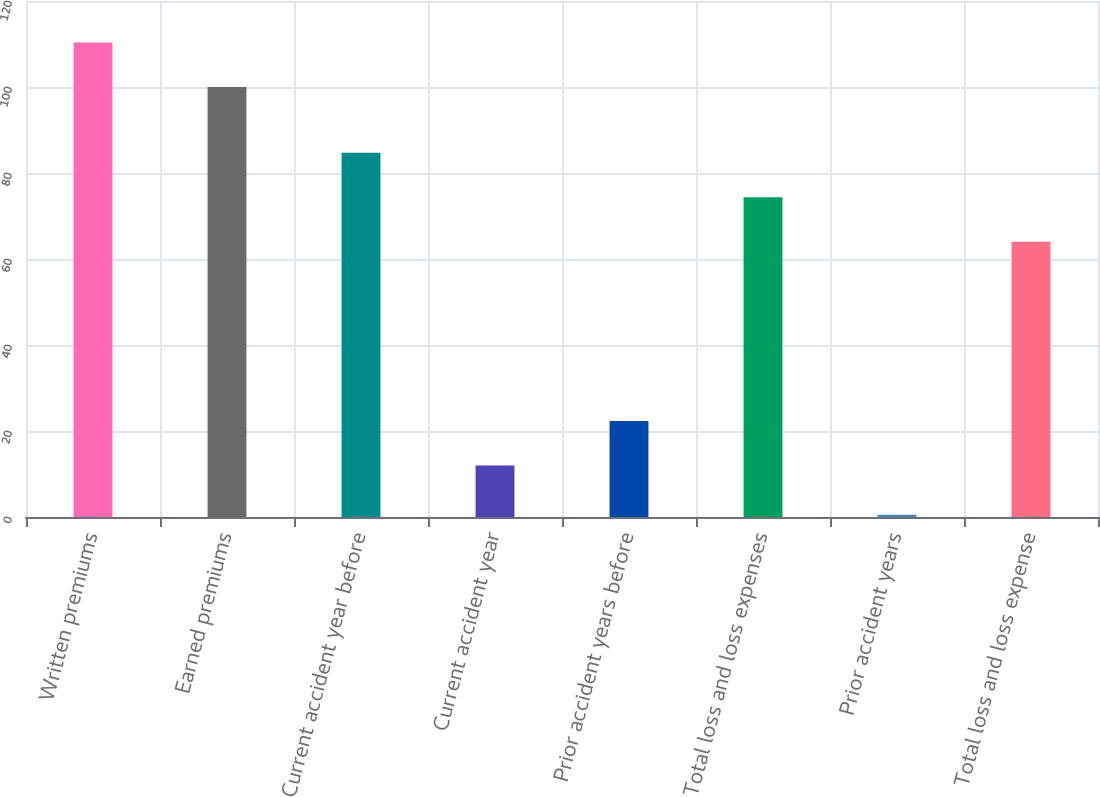Convert chart. <chart><loc_0><loc_0><loc_500><loc_500><bar_chart><fcel>Written premiums<fcel>Earned premiums<fcel>Current accident year before<fcel>Current accident year<fcel>Prior accident years before<fcel>Total loss and loss expenses<fcel>Prior accident years<fcel>Total loss and loss expense<nl><fcel>110.35<fcel>100<fcel>84.7<fcel>12<fcel>22.35<fcel>74.35<fcel>0.5<fcel>64<nl></chart> 